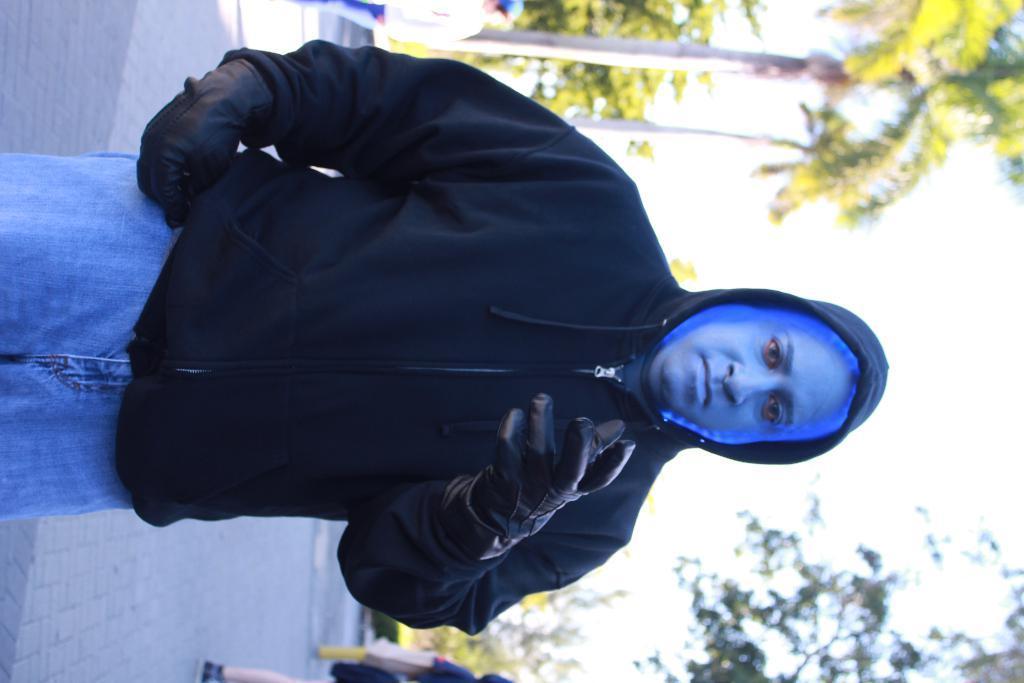Please provide a concise description of this image. In this picture we can see a man wore gloves and in the background we can see some persons standing on the ground, trees, sky. 